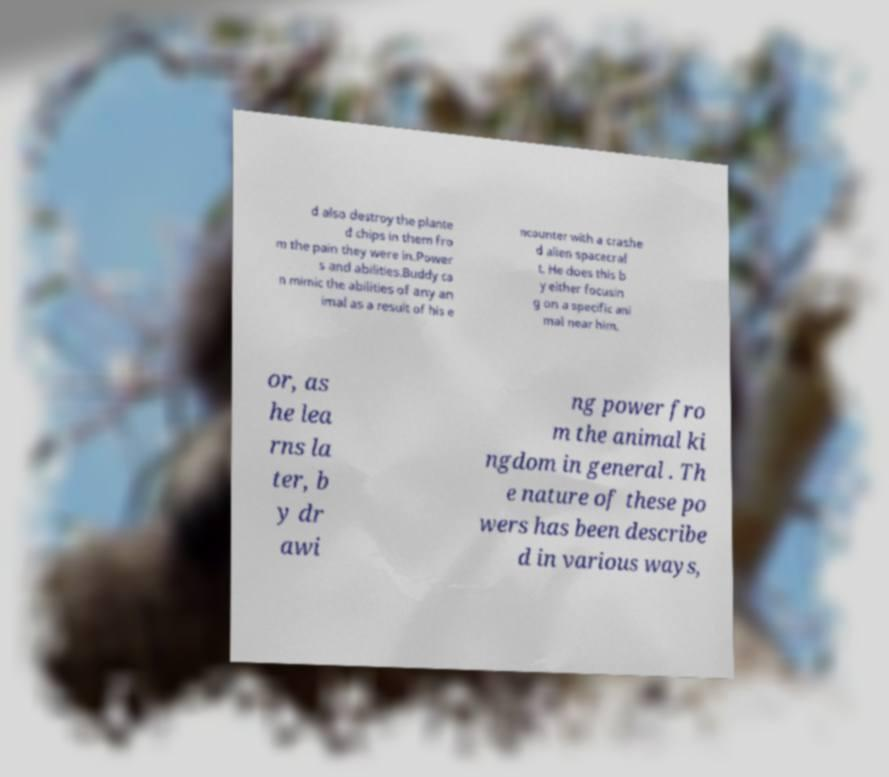Please read and relay the text visible in this image. What does it say? d also destroy the plante d chips in them fro m the pain they were in.Power s and abilities.Buddy ca n mimic the abilities of any an imal as a result of his e ncounter with a crashe d alien spacecraf t. He does this b y either focusin g on a specific ani mal near him, or, as he lea rns la ter, b y dr awi ng power fro m the animal ki ngdom in general . Th e nature of these po wers has been describe d in various ways, 